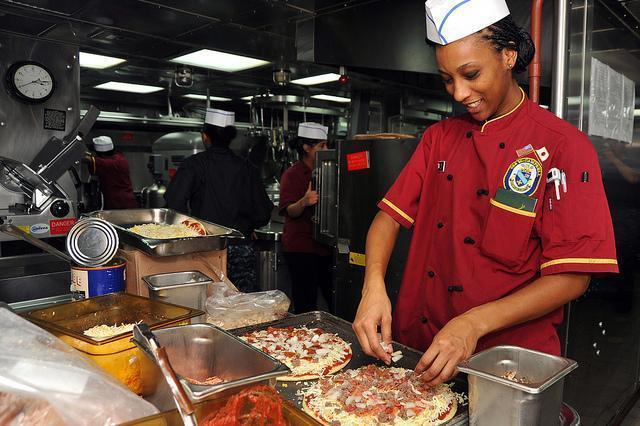What fungus is being added to this pie?
Choose the right answer from the provided options to respond to the question.
Options: Lichens, squash, mushrooms, algae. Mushrooms. What period of the day is it in the image?
From the following set of four choices, select the accurate answer to respond to the question.
Options: Night, morning, evening, afternoon. Afternoon. 